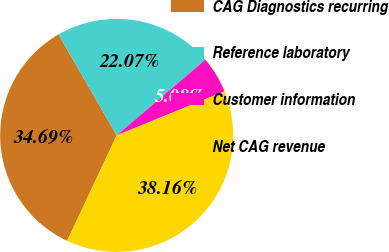Convert chart to OTSL. <chart><loc_0><loc_0><loc_500><loc_500><pie_chart><fcel>CAG Diagnostics recurring<fcel>Reference laboratory<fcel>Customer information<fcel>Net CAG revenue<nl><fcel>34.69%<fcel>22.07%<fcel>5.08%<fcel>38.16%<nl></chart> 